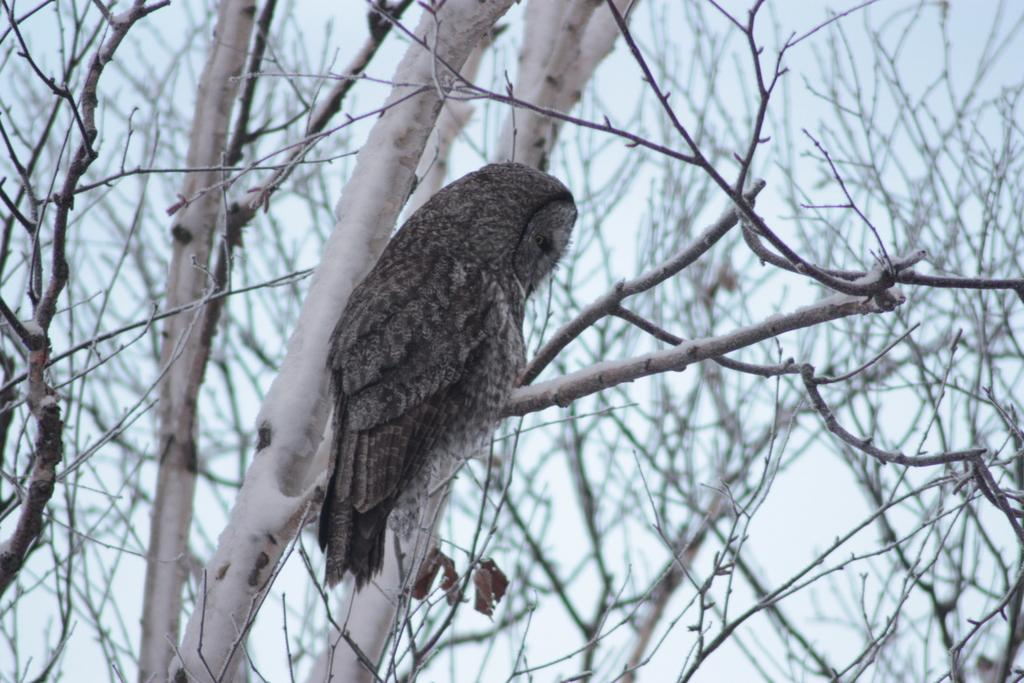What can be seen in the image? There is a tree in the image. Is there anything on the tree? Yes, there is a bird sitting on the tree. What decision did the men make in the image? There are no men present in the image, so no decision can be made by them. 